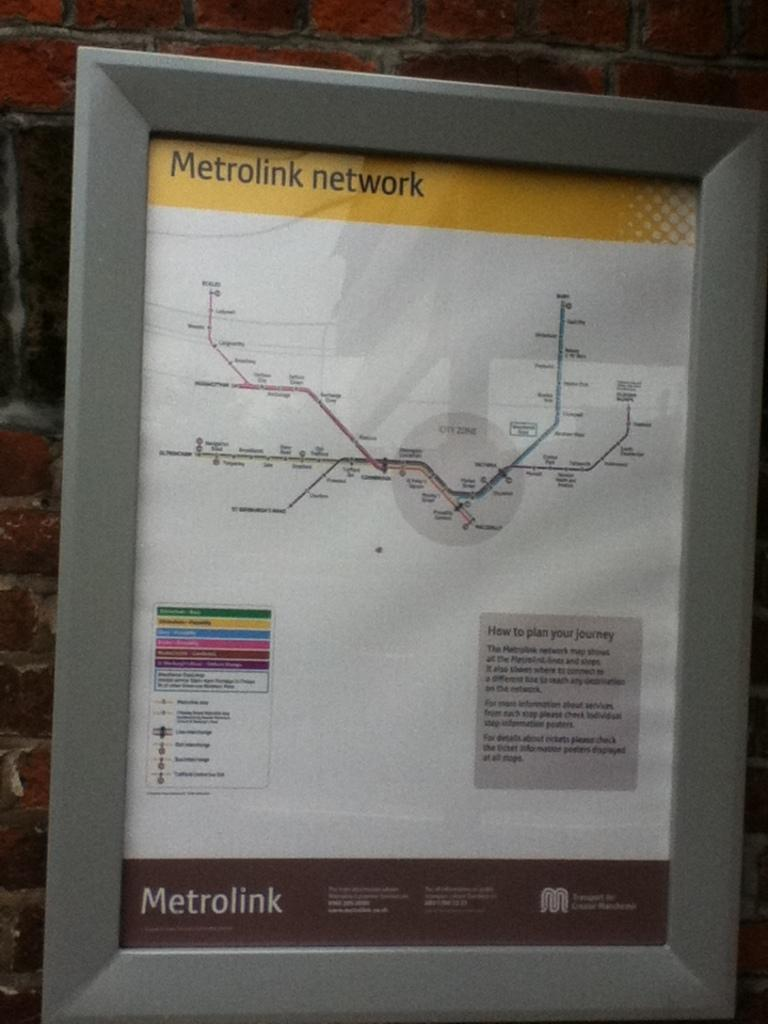<image>
Present a compact description of the photo's key features. A Metrolink network map pis displayed hanging on a brick wall with instructions for how to plan your journey. 